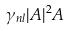Convert formula to latex. <formula><loc_0><loc_0><loc_500><loc_500>\gamma _ { n l } | A | ^ { 2 } A</formula> 